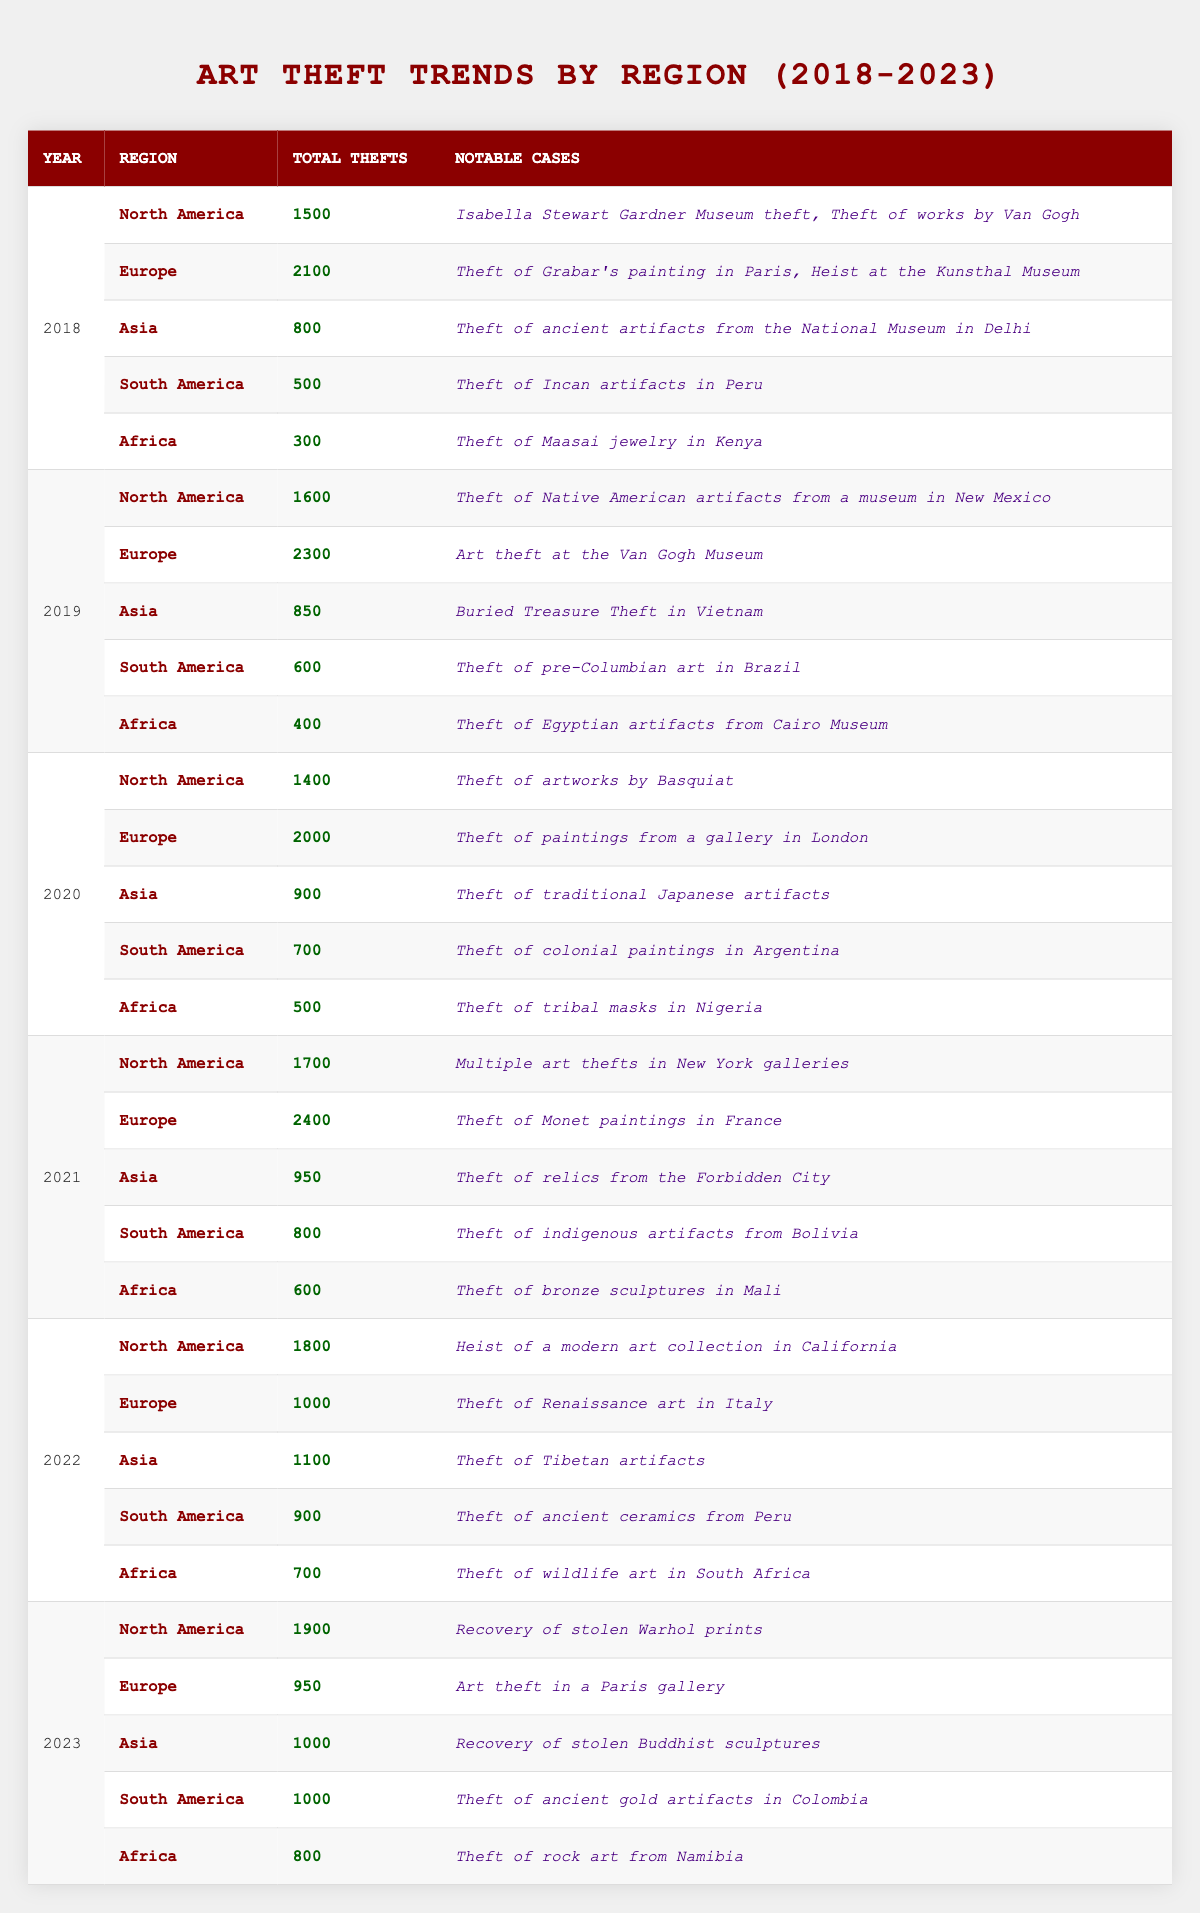What was the total number of art thefts in Europe in 2021? In 2021, the table shows that the total number of art thefts in Europe was 2400.
Answer: 2400 Which region had the highest total number of art thefts in 2020? According to the table, Europe had the highest number of art thefts in 2020 with a total of 2000.
Answer: Europe What is the change in total art thefts in North America from 2018 to 2023? The total thefts in North America increased from 1500 in 2018 to 1900 in 2023. The change is calculated as 1900 - 1500 = 400.
Answer: 400 Did Asia experience an increase in the total number of thefts from 2019 to 2022? In 2019, Asia had 850 thefts, and in 2022 it had 1100 thefts. The increase from 850 to 1100 indicates a yes to the question.
Answer: Yes What is the average number of art thefts across all regions in 2022? To find the average for 2022: (1800 + 1000 + 1100 + 900 + 700) = 4500 total thefts across five regions. The average is 4500 / 5 = 900.
Answer: 900 Which notable case was reported in Africa in 2021? The notable case reported in Africa in 2021 was the theft of bronze sculptures in Mali.
Answer: Theft of bronze sculptures in Mali What was the total number of thefts in South America from 2018 to 2023? The totals are: 500 (2018) + 600 (2019) + 700 (2020) + 800 (2021) + 900 (2022) + 1000 (2023). The total is 500 + 600 + 700 + 800 + 900 + 1000 = 3700.
Answer: 3700 Has the total number of art thefts in Europe decreased from 2021 to 2023? In 2021, the total was 2400, and in 2023 it decreased to 950. Thus, it shows a decrease indicating a yes to the question.
Answer: Yes In which year did North America report the highest number of total thefts and how many? The highest thefts reported in North America were in 2023 with a total of 1900.
Answer: 1900 What was the notable case in Asia for 2020? The notable case in Asia for 2020 is the theft of traditional Japanese artifacts.
Answer: Theft of traditional Japanese artifacts 